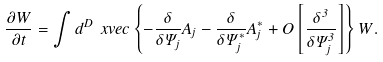Convert formula to latex. <formula><loc_0><loc_0><loc_500><loc_500>\frac { \partial W } { \partial t } = \int d ^ { D } \ x v e c \left \{ - \frac { \delta } { \delta \Psi _ { j } } A _ { j } - \frac { \delta } { \delta \Psi _ { j } ^ { * } } A _ { j } ^ { * } + O \left [ \frac { \delta ^ { 3 } } { \delta \Psi _ { j } ^ { 3 } } \right ] \right \} W .</formula> 